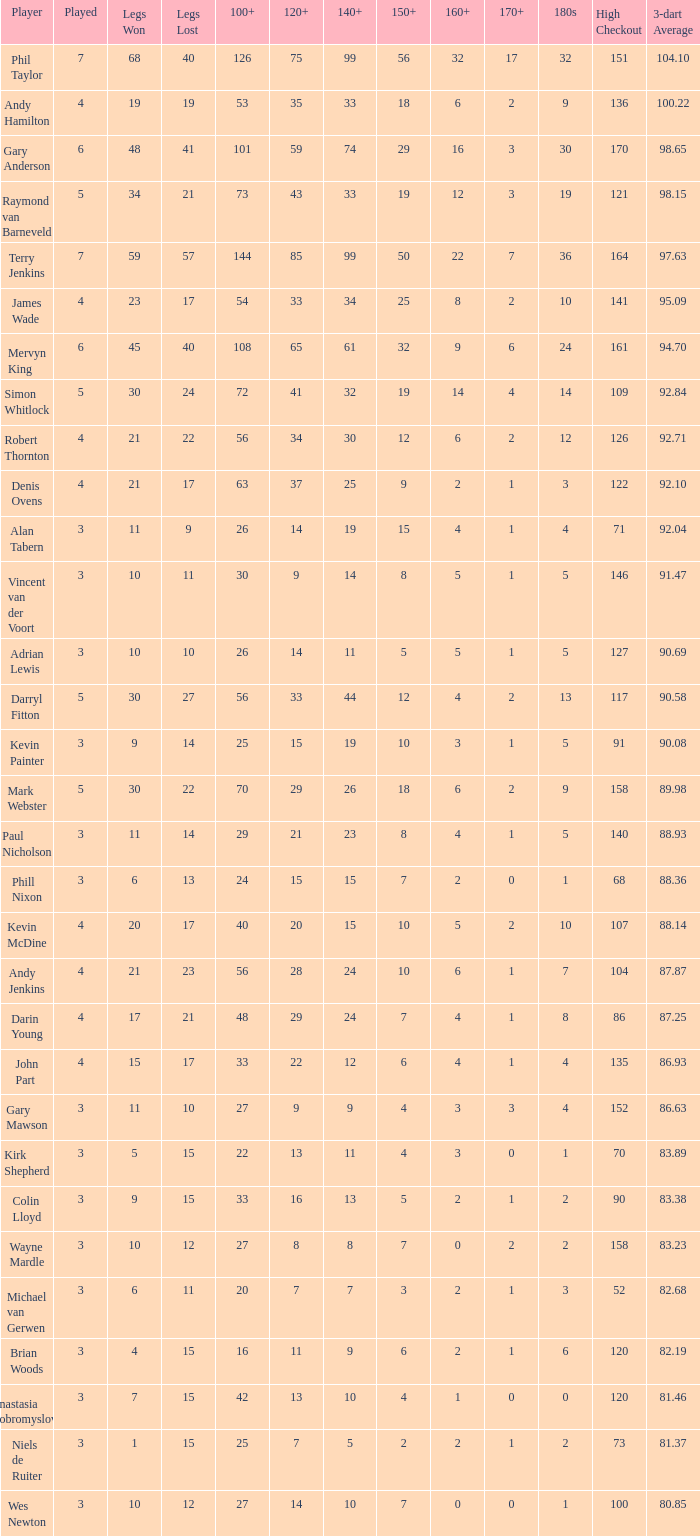Who is the player with 41 legs lost? Gary Anderson. 